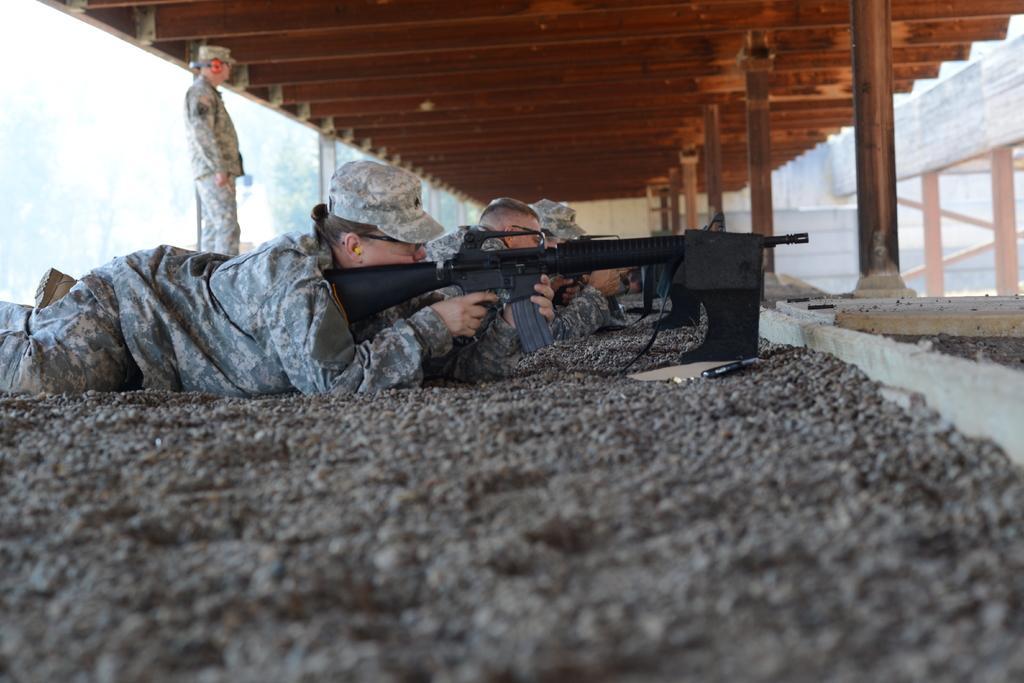In one or two sentences, can you explain what this image depicts? In this image I can see some people are lying on the ground holding a gun. 